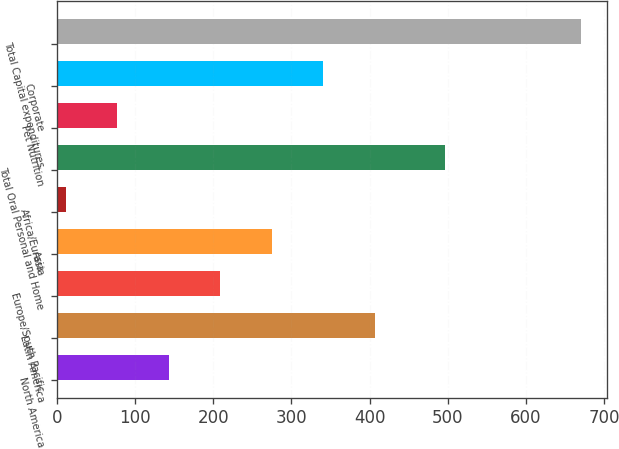<chart> <loc_0><loc_0><loc_500><loc_500><bar_chart><fcel>North America<fcel>Latin America<fcel>Europe/South Pacific<fcel>Asia<fcel>Africa/Eurasia<fcel>Total Oral Personal and Home<fcel>Pet Nutrition<fcel>Corporate<fcel>Total Capital expenditures<nl><fcel>142.8<fcel>406.4<fcel>208.7<fcel>274.6<fcel>11<fcel>497<fcel>76.9<fcel>340.5<fcel>670<nl></chart> 